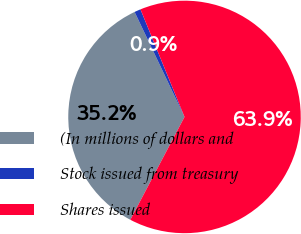<chart> <loc_0><loc_0><loc_500><loc_500><pie_chart><fcel>(In millions of dollars and<fcel>Stock issued from treasury<fcel>Shares issued<nl><fcel>35.22%<fcel>0.88%<fcel>63.9%<nl></chart> 